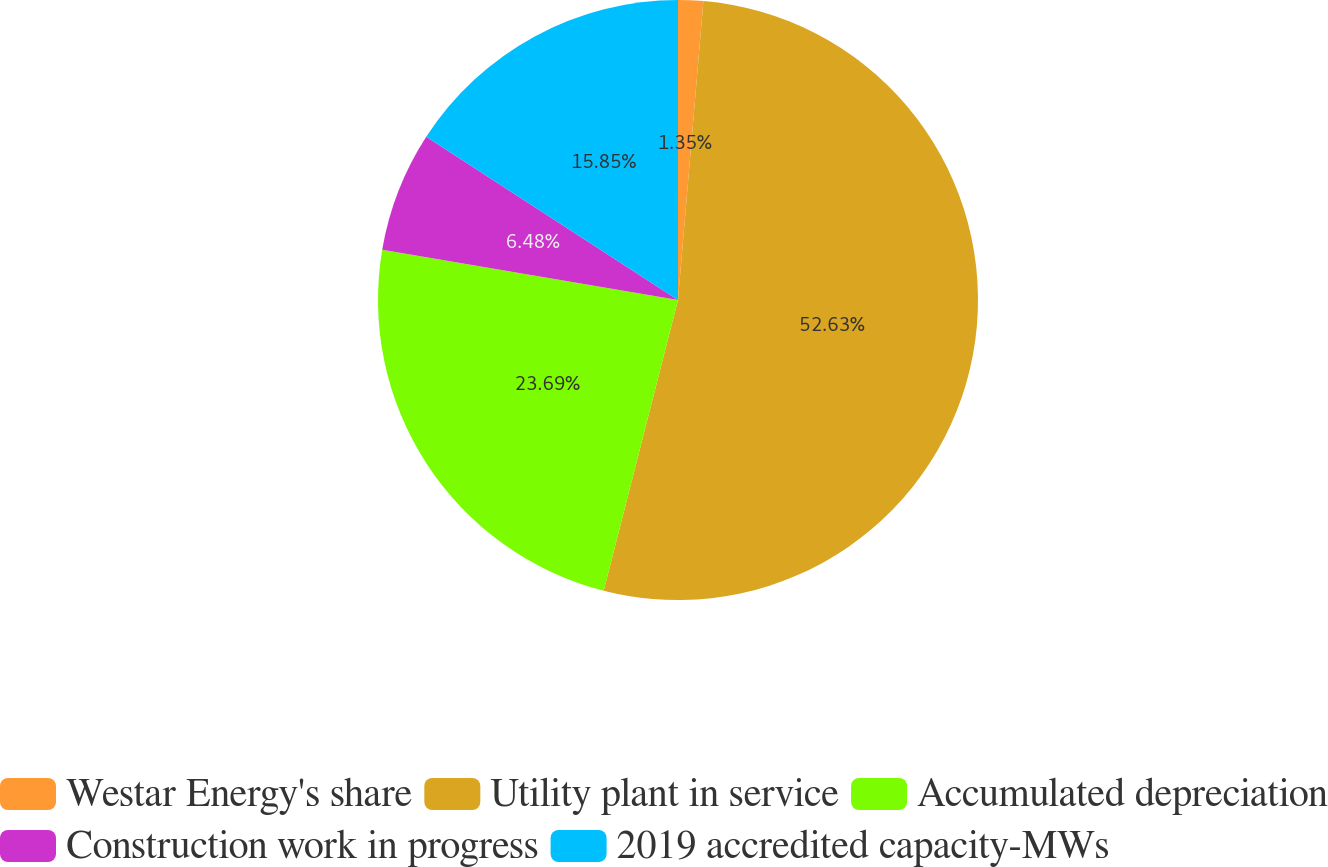<chart> <loc_0><loc_0><loc_500><loc_500><pie_chart><fcel>Westar Energy's share<fcel>Utility plant in service<fcel>Accumulated depreciation<fcel>Construction work in progress<fcel>2019 accredited capacity-MWs<nl><fcel>1.35%<fcel>52.64%<fcel>23.69%<fcel>6.48%<fcel>15.85%<nl></chart> 